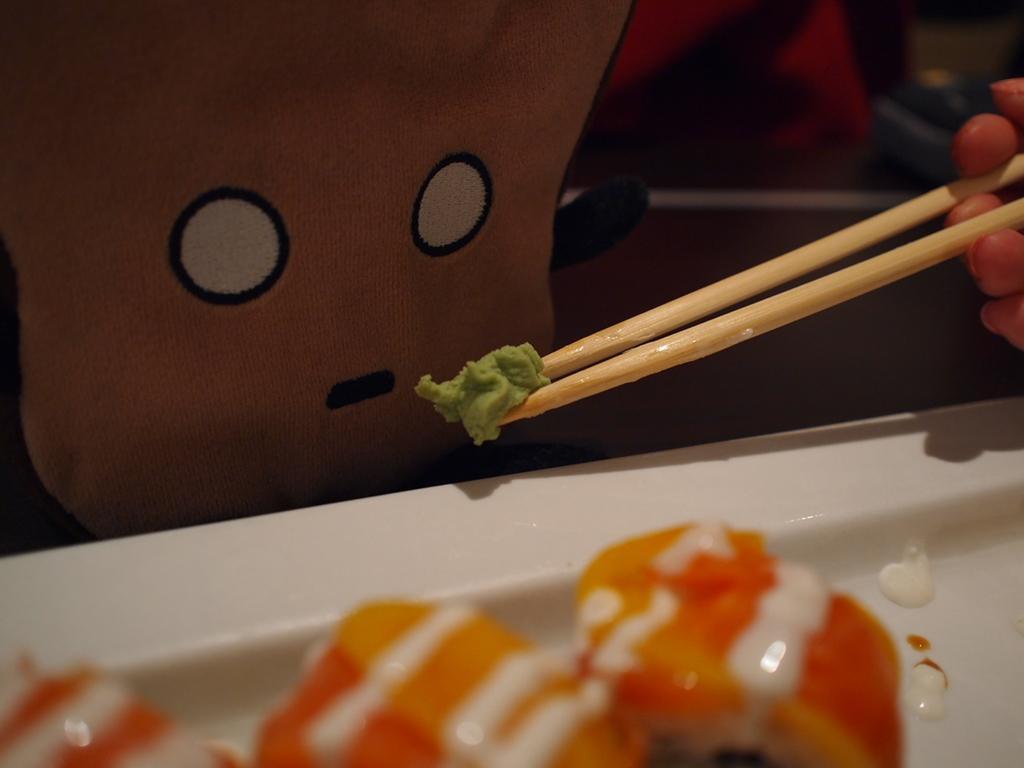In one or two sentences, can you explain what this image depicts? This image consist of a plate. In which there is food. To the right, there is a person holding chopsticks and food. In the background, there is a doll or emoji. 